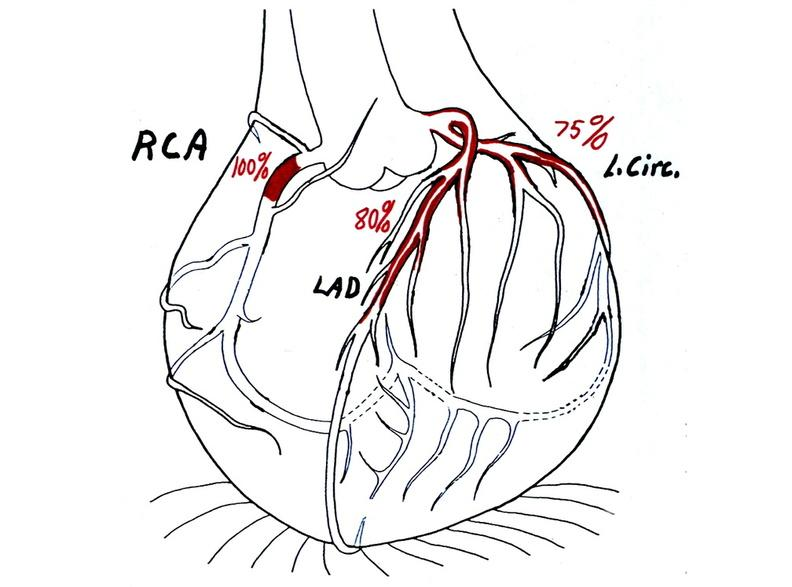what is present?
Answer the question using a single word or phrase. Cardiovascular 